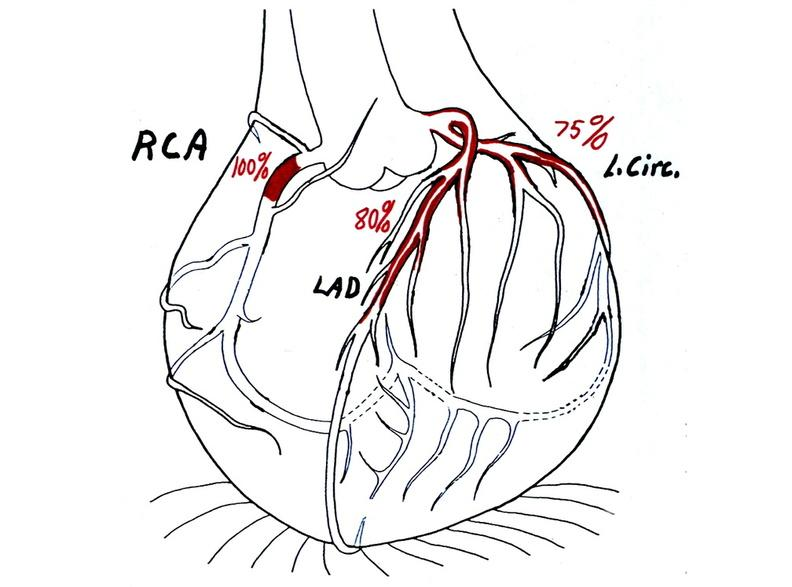what is present?
Answer the question using a single word or phrase. Cardiovascular 